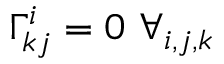<formula> <loc_0><loc_0><loc_500><loc_500>\Gamma _ { k j } ^ { i } = 0 \forall _ { i , j , k }</formula> 